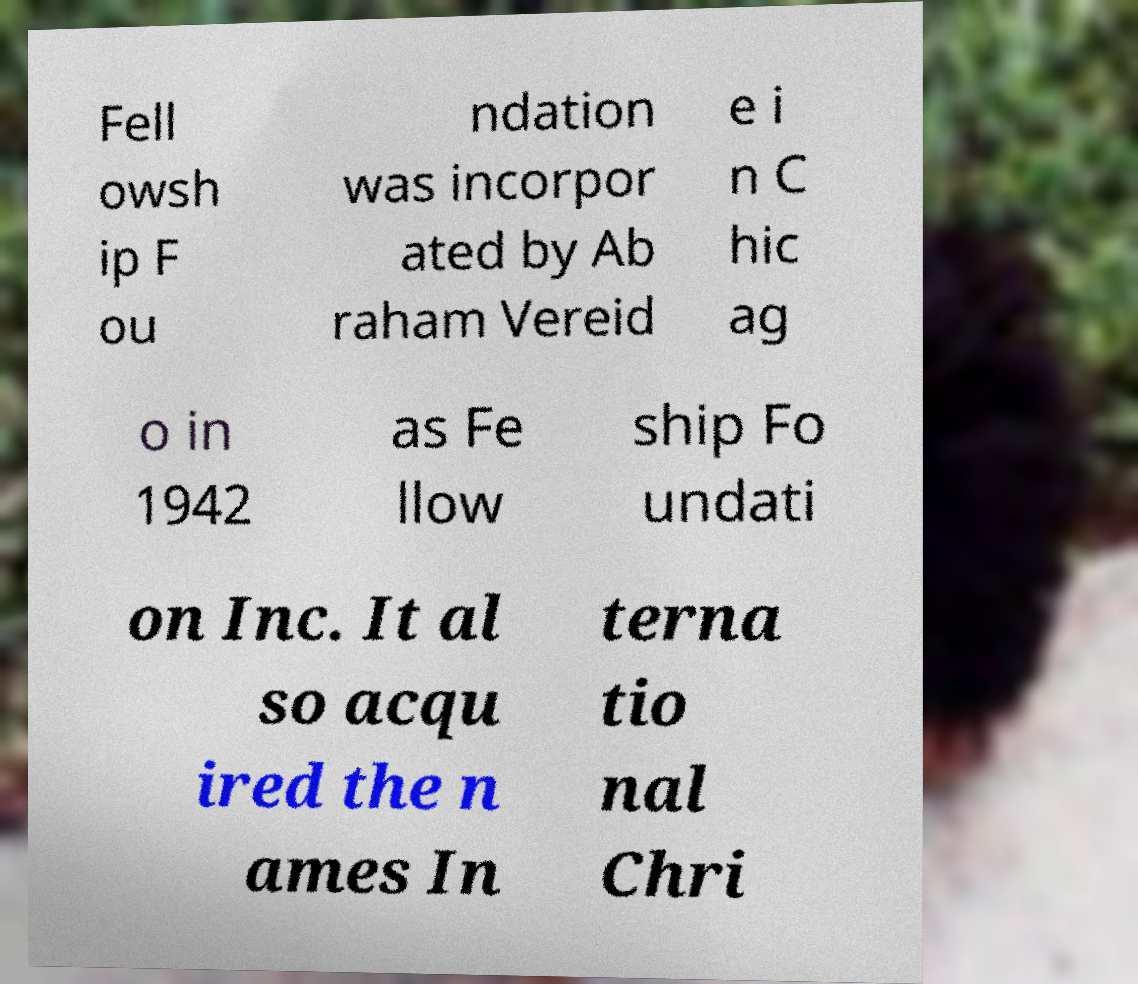Can you accurately transcribe the text from the provided image for me? Fell owsh ip F ou ndation was incorpor ated by Ab raham Vereid e i n C hic ag o in 1942 as Fe llow ship Fo undati on Inc. It al so acqu ired the n ames In terna tio nal Chri 